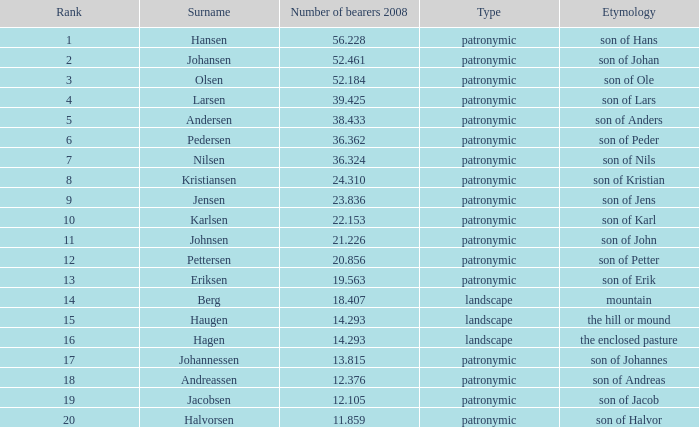What is Etymology, when Rank is 14? Mountain. 